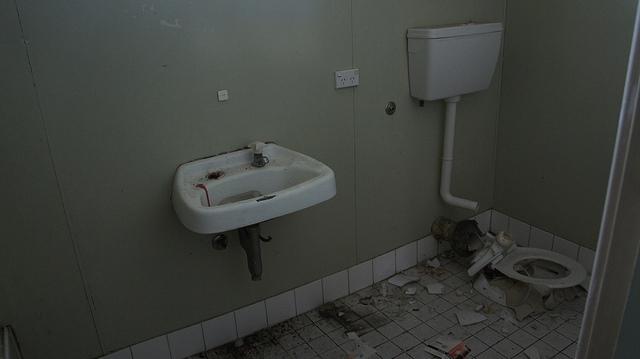Is the toilet seat broken?
Short answer required. Yes. Is this area large or small?
Concise answer only. Small. Was this restroom destroyed?
Keep it brief. Yes. Is this a well maintained bathroom?
Be succinct. No. What is attached to the wall over the toilet?
Keep it brief. Tank. Is this bathroom clean?
Keep it brief. No. Is the bathroom clean?
Write a very short answer. No. Is the bathroom clean or dirty?
Write a very short answer. Dirty. Is the toilet clean?
Be succinct. No. Is there a toilet in the bathroom?
Quick response, please. No. When is the last time this bathroom was cleaned?
Answer briefly. Long time ago. 